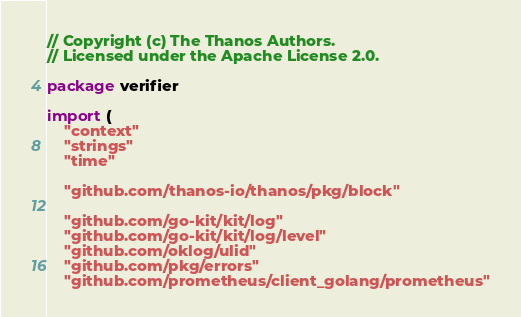Convert code to text. <code><loc_0><loc_0><loc_500><loc_500><_Go_>// Copyright (c) The Thanos Authors.
// Licensed under the Apache License 2.0.

package verifier

import (
	"context"
	"strings"
	"time"

	"github.com/thanos-io/thanos/pkg/block"

	"github.com/go-kit/kit/log"
	"github.com/go-kit/kit/log/level"
	"github.com/oklog/ulid"
	"github.com/pkg/errors"
	"github.com/prometheus/client_golang/prometheus"</code> 